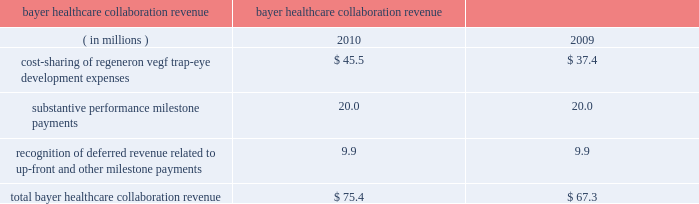Recognition of deferred revenue related to sanofi-aventis 2019 $ 85.0 million up-front payment decreased in 2010 compared to 2009 due to the november 2009 amendments to expand and extend the companies 2019 antibody collaboration .
In connection with the november 2009 amendment of the discovery agreement , sanofi-aventis is funding up to $ 30 million of agreed-upon costs incurred by us to expand our manufacturing capacity at our rensselaer , new york facilities , of which $ 23.4 million was received or receivable from sanofi-aventis as of december 31 , 2010 .
Revenue related to these payments for such funding from sanofi-aventis is deferred and recognized as collaboration revenue prospectively over the related performance period in conjunction with the recognition of the original $ 85.0 million up-front payment .
As of december 31 , 2010 , $ 79.8 million of the sanofi-aventis payments was deferred and will be recognized as revenue in future periods .
In august 2008 , we entered into a separate velocigene ae agreement with sanofi-aventis .
In 2010 and 2009 , we recognized $ 1.6 million and $ 2.7 million , respectively , in revenue related to this agreement .
Bayer healthcare collaboration revenue the collaboration revenue we earned from bayer healthcare , as detailed below , consisted of cost sharing of regeneron vegf trap-eye development expenses , substantive performance milestone payments , and recognition of revenue related to a non-refundable $ 75.0 million up-front payment received in october 2006 and a $ 20.0 million milestone payment received in august 2007 ( which , for the purpose of revenue recognition , was not considered substantive ) .
Years ended bayer healthcare collaboration revenue december 31 .
Cost-sharing of our vegf trap-eye development expenses with bayer healthcare increased in 2010 compared to 2009 due to higher internal development activities and higher clinical development costs in connection with our phase 3 copernicus trial in crvo .
In the fourth quarter of 2010 , we earned two $ 10.0 million substantive milestone payments from bayer healthcare for achieving positive 52-week results in the view 1 study and positive 6-month results in the copernicus study .
In july 2009 , we earned a $ 20.0 million substantive performance milestone payment from bayer healthcare in connection with the dosing of the first patient in the copernicus study .
In connection with the recognition of deferred revenue related to the $ 75.0 million up-front payment and $ 20.0 million milestone payment received in august 2007 , as of december 31 , 2010 , $ 47.0 million of these payments was deferred and will be recognized as revenue in future periods .
Technology licensing revenue in connection with our velocimmune ae license agreements with astrazeneca and astellas , each of the $ 20.0 million annual , non-refundable payments were deferred upon receipt and recognized as revenue ratably over approximately the ensuing year of each agreement .
In both 2010 and 2009 , we recognized $ 40.0 million of technology licensing revenue related to these agreements .
In addition , in connection with the amendment and extension of our license agreement with astellas , in august 2010 , we received a $ 165.0 million up-front payment , which was deferred upon receipt and will be recognized as revenue ratably over a seven-year period beginning in mid-2011 .
As of december 31 , 2010 , $ 176.6 million of these technology licensing payments was deferred and will be recognized as revenue in future periods .
Net product sales in 2010 and 2009 , we recognized as revenue $ 25.3 million and $ 18.4 million , respectively , of arcalyst ae net product sales for which both the right of return no longer existed and rebates could be reasonably estimated .
The company had limited historical return experience for arcalyst ae beginning with initial sales in 2008 through the end of 2009 ; therefore , arcalyst ae net product sales were deferred until the right of return no longer existed and rebates could be reasonably estimated .
Effective in the first quarter of 2010 , the company determined that it had .
What was the total in 2010 and 2009 for arcalyst ae net product sales? 
Computations: ((25.3 + 18.4) * 1000000)
Answer: 43700000.0. 